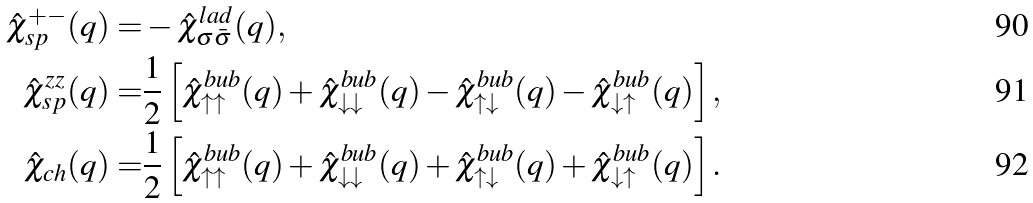<formula> <loc_0><loc_0><loc_500><loc_500>\hat { \chi } _ { s p } ^ { + - } ( q ) = & - \hat { \chi } _ { \sigma \bar { \sigma } } ^ { l a d } ( q ) , \\ \hat { \chi } _ { s p } ^ { z z } ( q ) = & \frac { 1 } { 2 } \left [ \hat { \chi } _ { \uparrow \uparrow } ^ { b u b } ( q ) + \hat { \chi } _ { \downarrow \downarrow } ^ { b u b } ( q ) - \hat { \chi } _ { \uparrow \downarrow } ^ { b u b } ( q ) - \hat { \chi } _ { \downarrow \uparrow } ^ { b u b } ( q ) \right ] , \\ \hat { \chi } _ { c h } ( q ) = & \frac { 1 } { 2 } \left [ \hat { \chi } _ { \uparrow \uparrow } ^ { b u b } ( q ) + \hat { \chi } _ { \downarrow \downarrow } ^ { b u b } ( q ) + \hat { \chi } _ { \uparrow \downarrow } ^ { b u b } ( q ) + \hat { \chi } _ { \downarrow \uparrow } ^ { b u b } ( q ) \right ] .</formula> 